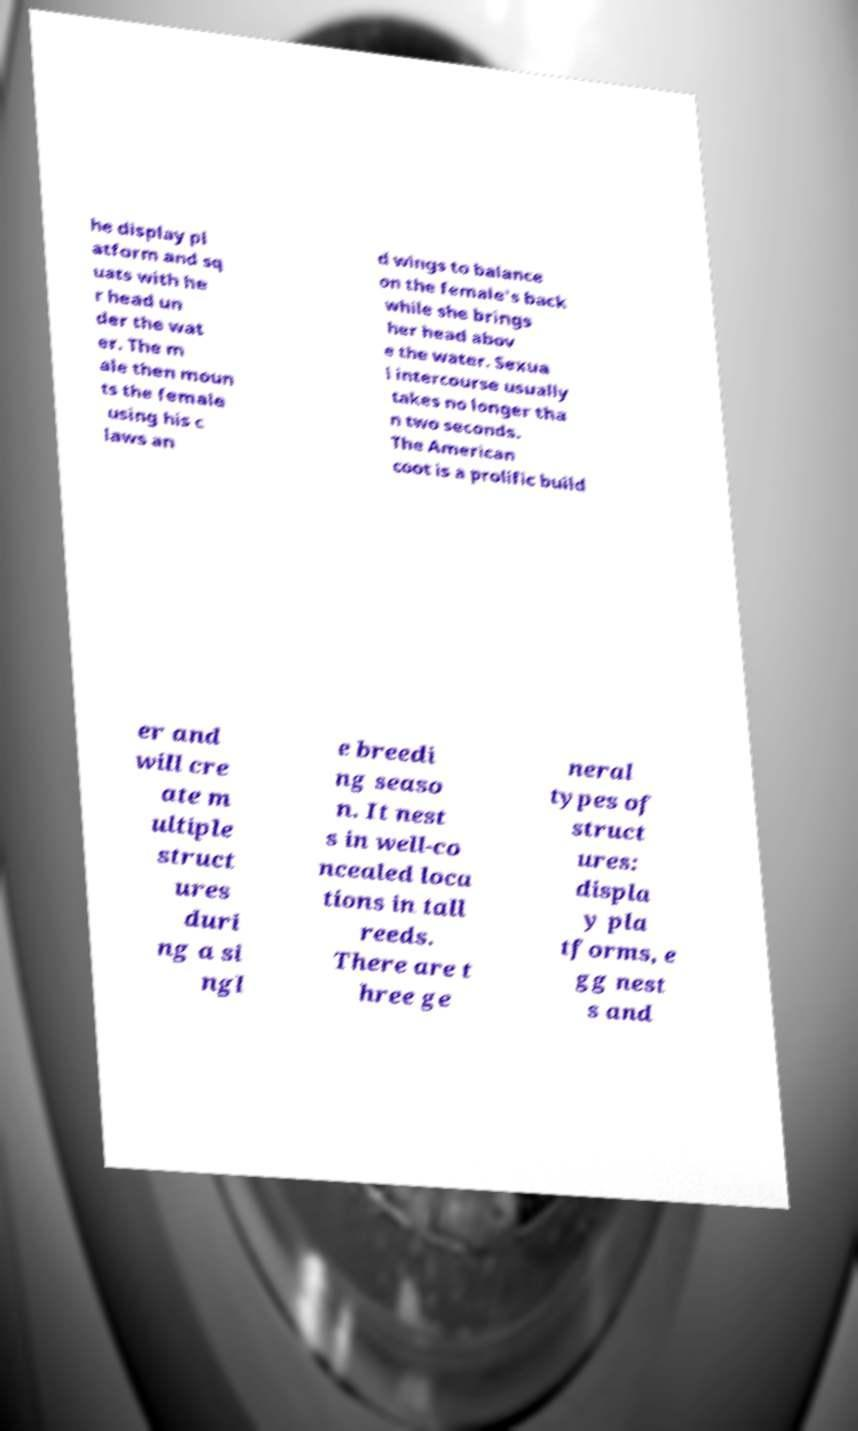Can you accurately transcribe the text from the provided image for me? he display pl atform and sq uats with he r head un der the wat er. The m ale then moun ts the female using his c laws an d wings to balance on the female's back while she brings her head abov e the water. Sexua l intercourse usually takes no longer tha n two seconds. The American coot is a prolific build er and will cre ate m ultiple struct ures duri ng a si ngl e breedi ng seaso n. It nest s in well-co ncealed loca tions in tall reeds. There are t hree ge neral types of struct ures: displa y pla tforms, e gg nest s and 